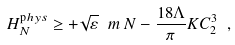Convert formula to latex. <formula><loc_0><loc_0><loc_500><loc_500>H ^ { \mathrm p h y s } _ { N } \geq + \sqrt { \varepsilon } \ m \, N - \frac { 1 8 \Lambda } { \pi } K C _ { 2 } ^ { 3 } \ ,</formula> 